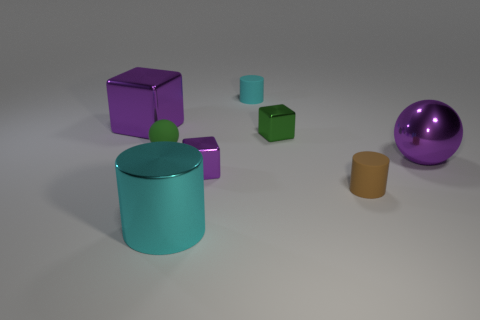Is the number of large purple shiny balls on the left side of the big purple metal cube less than the number of small cyan metal blocks?
Offer a very short reply. No. Is the number of brown matte cylinders behind the tiny cyan cylinder less than the number of brown matte objects that are left of the small brown object?
Your answer should be compact. No. How many cylinders are either small blue rubber things or green shiny things?
Your response must be concise. 0. Do the purple object behind the small matte sphere and the tiny green thing on the left side of the cyan metallic cylinder have the same material?
Provide a short and direct response. No. The cyan matte thing that is the same size as the green metallic thing is what shape?
Your response must be concise. Cylinder. What number of other things are there of the same color as the shiny ball?
Your answer should be very brief. 2. How many green objects are either rubber things or tiny matte cylinders?
Make the answer very short. 1. Does the purple metal thing left of the tiny purple metal thing have the same shape as the big purple object right of the small cyan rubber cylinder?
Ensure brevity in your answer.  No. What number of other things are made of the same material as the small brown thing?
Ensure brevity in your answer.  2. Are there any big purple cubes to the right of the small rubber cylinder in front of the purple metallic cube that is to the left of the green rubber sphere?
Give a very brief answer. No. 